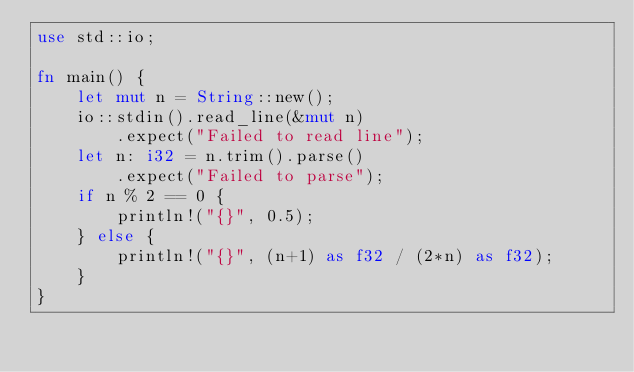<code> <loc_0><loc_0><loc_500><loc_500><_Rust_>use std::io;

fn main() {
    let mut n = String::new();
    io::stdin().read_line(&mut n)
        .expect("Failed to read line");
    let n: i32 = n.trim().parse()
        .expect("Failed to parse");
    if n % 2 == 0 {
        println!("{}", 0.5);
    } else {
        println!("{}", (n+1) as f32 / (2*n) as f32);
    }
}
</code> 